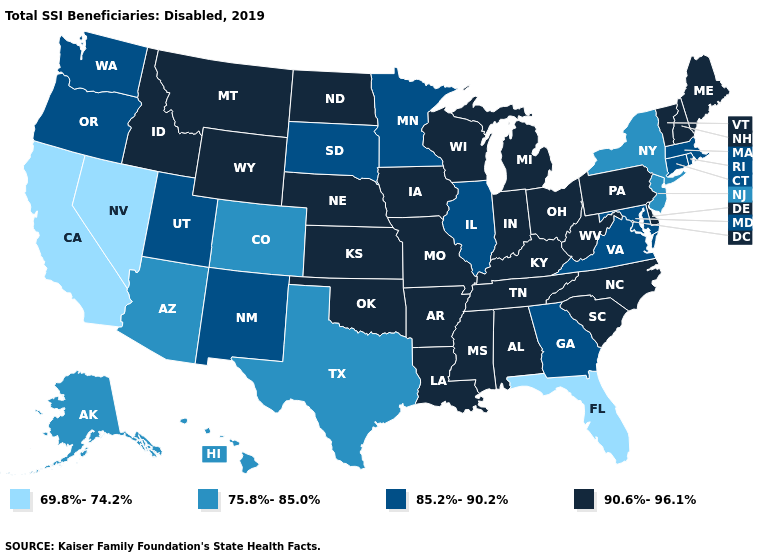Name the states that have a value in the range 90.6%-96.1%?
Give a very brief answer. Alabama, Arkansas, Delaware, Idaho, Indiana, Iowa, Kansas, Kentucky, Louisiana, Maine, Michigan, Mississippi, Missouri, Montana, Nebraska, New Hampshire, North Carolina, North Dakota, Ohio, Oklahoma, Pennsylvania, South Carolina, Tennessee, Vermont, West Virginia, Wisconsin, Wyoming. Name the states that have a value in the range 90.6%-96.1%?
Quick response, please. Alabama, Arkansas, Delaware, Idaho, Indiana, Iowa, Kansas, Kentucky, Louisiana, Maine, Michigan, Mississippi, Missouri, Montana, Nebraska, New Hampshire, North Carolina, North Dakota, Ohio, Oklahoma, Pennsylvania, South Carolina, Tennessee, Vermont, West Virginia, Wisconsin, Wyoming. Among the states that border Wisconsin , which have the highest value?
Answer briefly. Iowa, Michigan. What is the highest value in the USA?
Write a very short answer. 90.6%-96.1%. What is the value of Vermont?
Keep it brief. 90.6%-96.1%. What is the value of Idaho?
Short answer required. 90.6%-96.1%. What is the highest value in states that border Arkansas?
Concise answer only. 90.6%-96.1%. Does New York have the same value as Montana?
Be succinct. No. What is the value of Minnesota?
Quick response, please. 85.2%-90.2%. What is the lowest value in the South?
Give a very brief answer. 69.8%-74.2%. What is the highest value in the Northeast ?
Be succinct. 90.6%-96.1%. What is the lowest value in the USA?
Keep it brief. 69.8%-74.2%. Name the states that have a value in the range 90.6%-96.1%?
Short answer required. Alabama, Arkansas, Delaware, Idaho, Indiana, Iowa, Kansas, Kentucky, Louisiana, Maine, Michigan, Mississippi, Missouri, Montana, Nebraska, New Hampshire, North Carolina, North Dakota, Ohio, Oklahoma, Pennsylvania, South Carolina, Tennessee, Vermont, West Virginia, Wisconsin, Wyoming. Name the states that have a value in the range 69.8%-74.2%?
Write a very short answer. California, Florida, Nevada. 